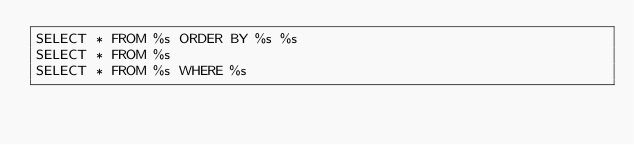Convert code to text. <code><loc_0><loc_0><loc_500><loc_500><_SQL_>SELECT * FROM %s ORDER BY %s %s
SELECT * FROM %s
SELECT * FROM %s WHERE %s
</code> 